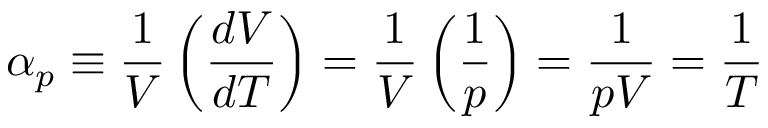Convert formula to latex. <formula><loc_0><loc_0><loc_500><loc_500>\alpha _ { p } \equiv \frac { 1 } { V } \left ( { \frac { d V } { d T } } \right ) = { \frac { 1 } { V } } \left ( { \frac { 1 } { p } } \right ) = { \frac { 1 } { p V } } = { \frac { 1 } { T } }</formula> 